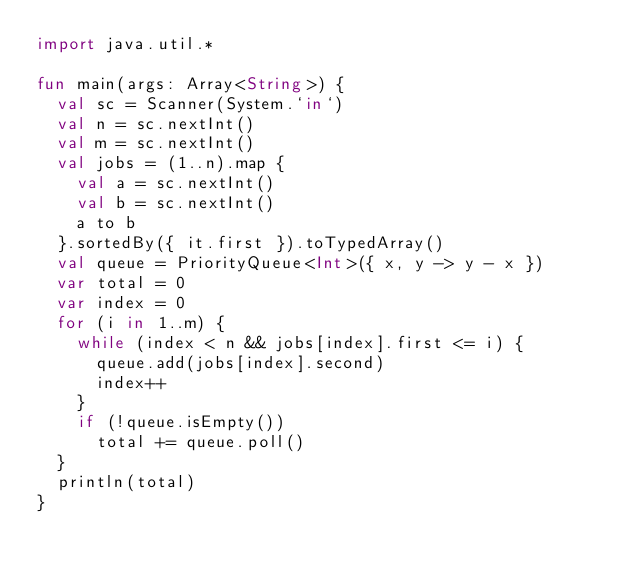Convert code to text. <code><loc_0><loc_0><loc_500><loc_500><_Kotlin_>import java.util.*

fun main(args: Array<String>) {
  val sc = Scanner(System.`in`)
  val n = sc.nextInt()
  val m = sc.nextInt()
  val jobs = (1..n).map {
    val a = sc.nextInt()
    val b = sc.nextInt()
    a to b
  }.sortedBy({ it.first }).toTypedArray()
  val queue = PriorityQueue<Int>({ x, y -> y - x })
  var total = 0
  var index = 0
  for (i in 1..m) {
    while (index < n && jobs[index].first <= i) {
      queue.add(jobs[index].second)
      index++
    }
    if (!queue.isEmpty())
      total += queue.poll()
  }
  println(total)
}
</code> 